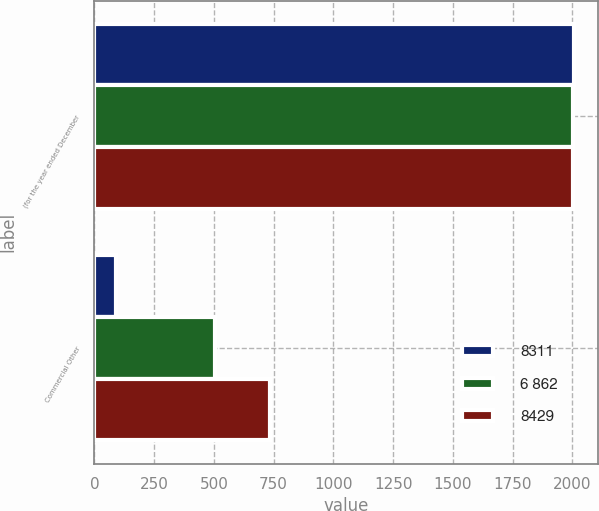Convert chart. <chart><loc_0><loc_0><loc_500><loc_500><stacked_bar_chart><ecel><fcel>(for the year ended December<fcel>Commercial Other<nl><fcel>8311<fcel>2005<fcel>91<nl><fcel>6 862<fcel>2004<fcel>506<nl><fcel>8429<fcel>2003<fcel>733<nl></chart> 